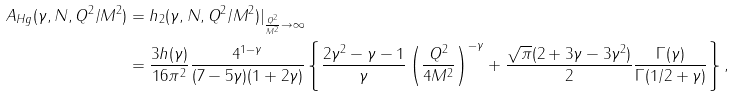Convert formula to latex. <formula><loc_0><loc_0><loc_500><loc_500>A _ { H g } ( \gamma , N , Q ^ { 2 } / M ^ { 2 } ) & = h _ { 2 } ( \gamma , N , Q ^ { 2 } / M ^ { 2 } ) | _ { \frac { Q ^ { 2 } } { M ^ { 2 } } \rightarrow \infty } \\ & = \frac { 3 h ( \gamma ) } { 1 6 \pi ^ { 2 } } \frac { 4 ^ { 1 - \gamma } } { ( 7 - 5 \gamma ) ( 1 + 2 \gamma ) } \left \{ \frac { 2 \gamma ^ { 2 } - \gamma - 1 } { \gamma } \left ( \frac { Q ^ { 2 } } { 4 M ^ { 2 } } \right ) ^ { - \gamma } + \frac { \sqrt { \pi } ( 2 + 3 \gamma - 3 \gamma ^ { 2 } ) } { 2 } \frac { \Gamma ( \gamma ) } { \Gamma ( 1 / 2 + \gamma ) } \right \} ,</formula> 